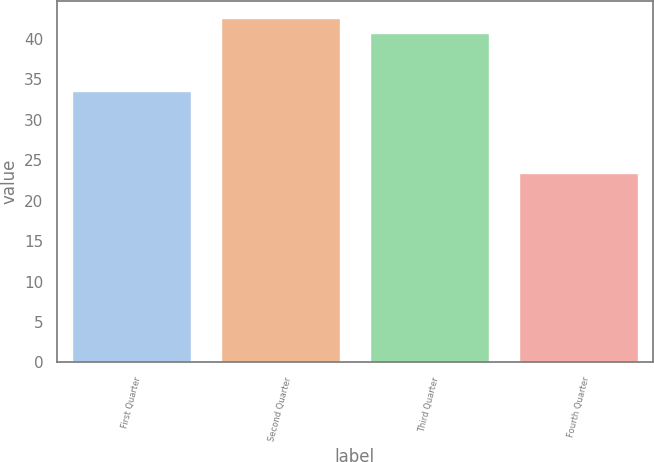Convert chart to OTSL. <chart><loc_0><loc_0><loc_500><loc_500><bar_chart><fcel>First Quarter<fcel>Second Quarter<fcel>Third Quarter<fcel>Fourth Quarter<nl><fcel>33.54<fcel>42.62<fcel>40.74<fcel>23.39<nl></chart> 